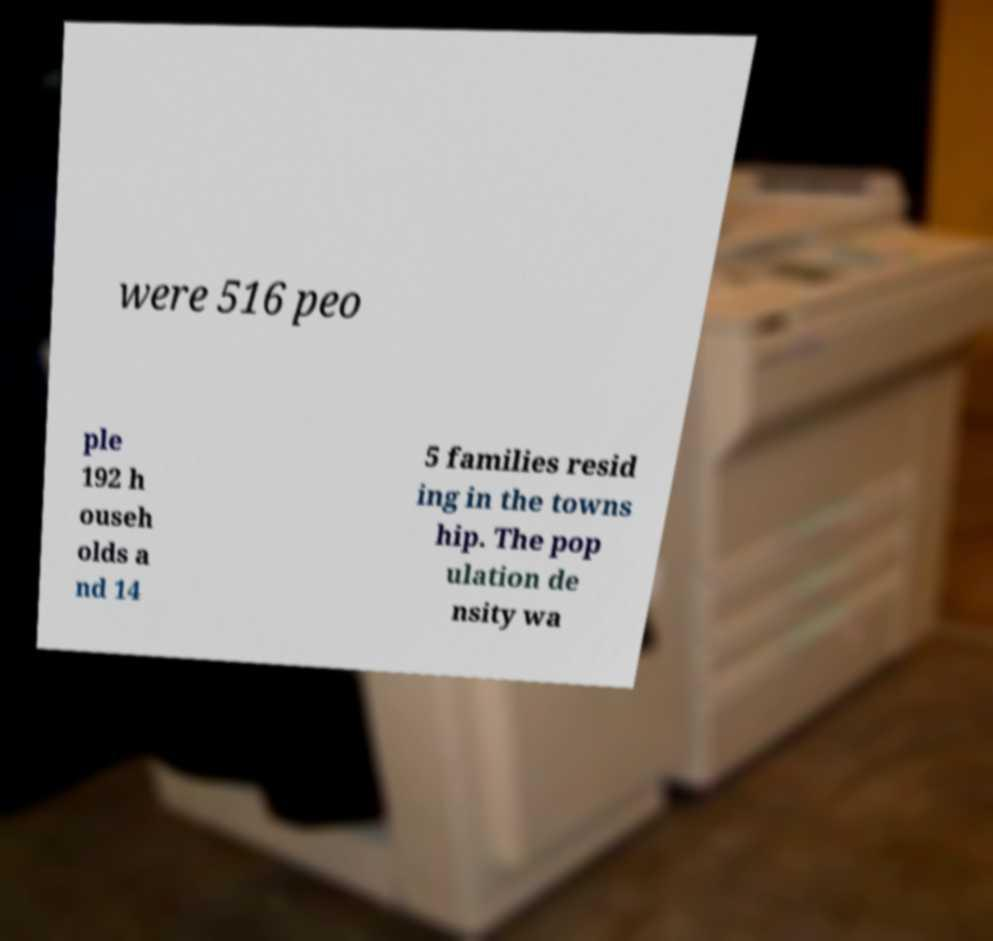Please read and relay the text visible in this image. What does it say? were 516 peo ple 192 h ouseh olds a nd 14 5 families resid ing in the towns hip. The pop ulation de nsity wa 